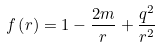Convert formula to latex. <formula><loc_0><loc_0><loc_500><loc_500>f \left ( r \right ) = 1 - \frac { 2 m } r + \frac { q ^ { 2 } } { r ^ { 2 } }</formula> 